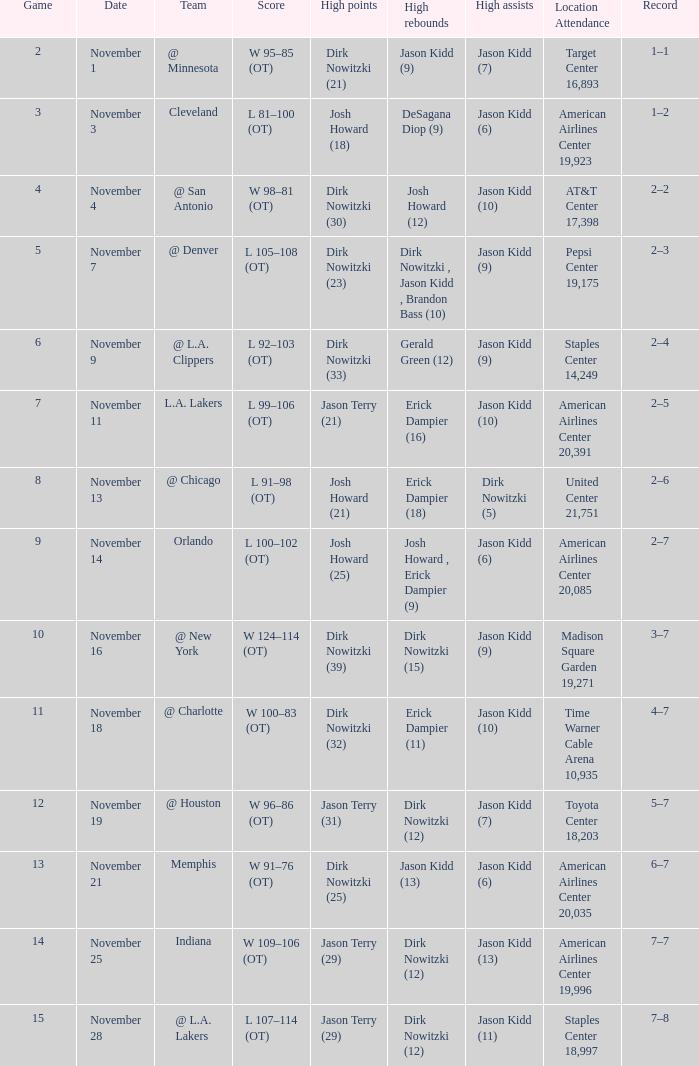What was the achievement on november 1? 1–1. 